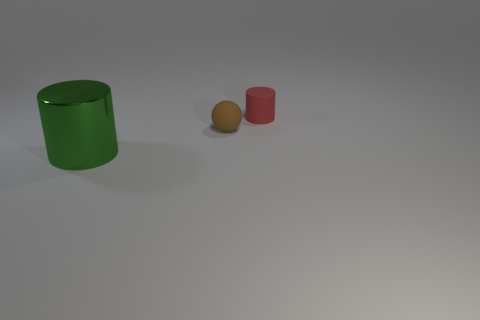Is there any other thing that has the same material as the big green object?
Provide a short and direct response. No. Is the number of large shiny objects that are on the right side of the red matte cylinder less than the number of big metal cylinders?
Offer a very short reply. Yes. What is the shape of the tiny red object that is the same material as the sphere?
Ensure brevity in your answer.  Cylinder. What number of small rubber objects are the same color as the small cylinder?
Provide a short and direct response. 0. What number of things are either red objects or green metal balls?
Provide a succinct answer. 1. There is a cylinder that is behind the green metallic cylinder that is to the left of the tiny matte ball; what is its material?
Keep it short and to the point. Rubber. Is there a brown ball made of the same material as the small red cylinder?
Your response must be concise. Yes. The big thing on the left side of the cylinder that is behind the green metallic thing in front of the small red matte thing is what shape?
Give a very brief answer. Cylinder. What material is the tiny brown thing?
Provide a short and direct response. Rubber. There is another small thing that is the same material as the red object; what color is it?
Provide a short and direct response. Brown. 